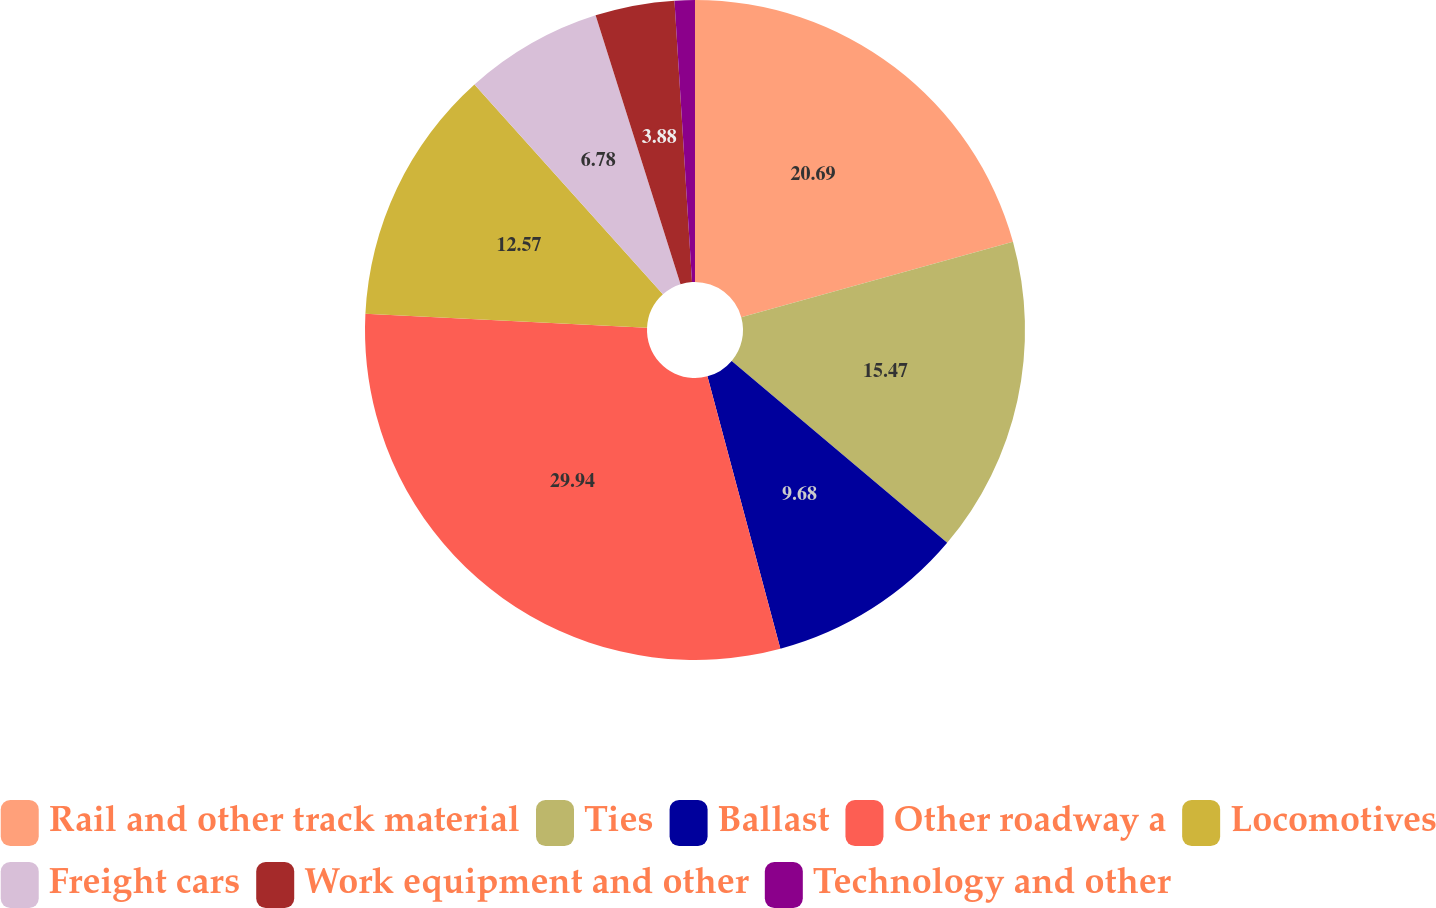Convert chart. <chart><loc_0><loc_0><loc_500><loc_500><pie_chart><fcel>Rail and other track material<fcel>Ties<fcel>Ballast<fcel>Other roadway a<fcel>Locomotives<fcel>Freight cars<fcel>Work equipment and other<fcel>Technology and other<nl><fcel>20.69%<fcel>15.47%<fcel>9.68%<fcel>29.95%<fcel>12.57%<fcel>6.78%<fcel>3.88%<fcel>0.99%<nl></chart> 